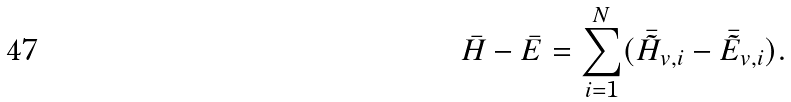Convert formula to latex. <formula><loc_0><loc_0><loc_500><loc_500>\bar { H } - \bar { E } = \sum _ { i = 1 } ^ { N } ( \bar { \tilde { H } } _ { v , i } - \bar { \tilde { E } } _ { v , i } ) .</formula> 